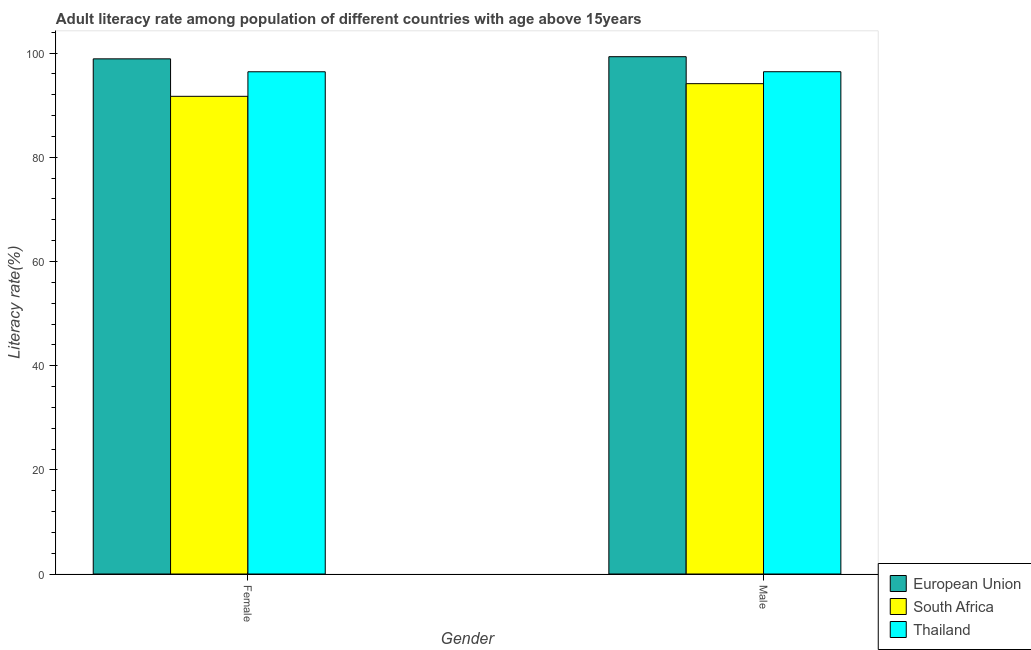How many different coloured bars are there?
Offer a very short reply. 3. What is the female adult literacy rate in Thailand?
Provide a short and direct response. 96.43. Across all countries, what is the maximum female adult literacy rate?
Ensure brevity in your answer.  98.91. Across all countries, what is the minimum male adult literacy rate?
Your response must be concise. 94.14. In which country was the female adult literacy rate maximum?
Provide a short and direct response. European Union. In which country was the female adult literacy rate minimum?
Ensure brevity in your answer.  South Africa. What is the total female adult literacy rate in the graph?
Your answer should be compact. 287.05. What is the difference between the female adult literacy rate in European Union and that in Thailand?
Make the answer very short. 2.48. What is the difference between the male adult literacy rate in European Union and the female adult literacy rate in South Africa?
Offer a very short reply. 7.61. What is the average female adult literacy rate per country?
Offer a very short reply. 95.68. What is the difference between the female adult literacy rate and male adult literacy rate in European Union?
Your answer should be very brief. -0.41. What is the ratio of the female adult literacy rate in Thailand to that in South Africa?
Ensure brevity in your answer.  1.05. Is the female adult literacy rate in Thailand less than that in European Union?
Ensure brevity in your answer.  Yes. What does the 1st bar from the left in Male represents?
Your answer should be very brief. European Union. How many bars are there?
Give a very brief answer. 6. Are all the bars in the graph horizontal?
Provide a succinct answer. No. How many countries are there in the graph?
Your answer should be compact. 3. Are the values on the major ticks of Y-axis written in scientific E-notation?
Provide a succinct answer. No. Does the graph contain any zero values?
Keep it short and to the point. No. What is the title of the graph?
Your answer should be compact. Adult literacy rate among population of different countries with age above 15years. Does "South Africa" appear as one of the legend labels in the graph?
Ensure brevity in your answer.  Yes. What is the label or title of the Y-axis?
Your answer should be very brief. Literacy rate(%). What is the Literacy rate(%) in European Union in Female?
Provide a short and direct response. 98.91. What is the Literacy rate(%) in South Africa in Female?
Offer a terse response. 91.71. What is the Literacy rate(%) of Thailand in Female?
Offer a terse response. 96.43. What is the Literacy rate(%) in European Union in Male?
Keep it short and to the point. 99.32. What is the Literacy rate(%) of South Africa in Male?
Ensure brevity in your answer.  94.14. What is the Literacy rate(%) in Thailand in Male?
Provide a succinct answer. 96.44. Across all Gender, what is the maximum Literacy rate(%) of European Union?
Your response must be concise. 99.32. Across all Gender, what is the maximum Literacy rate(%) in South Africa?
Make the answer very short. 94.14. Across all Gender, what is the maximum Literacy rate(%) of Thailand?
Your answer should be compact. 96.44. Across all Gender, what is the minimum Literacy rate(%) of European Union?
Make the answer very short. 98.91. Across all Gender, what is the minimum Literacy rate(%) of South Africa?
Keep it short and to the point. 91.71. Across all Gender, what is the minimum Literacy rate(%) of Thailand?
Give a very brief answer. 96.43. What is the total Literacy rate(%) of European Union in the graph?
Your response must be concise. 198.23. What is the total Literacy rate(%) of South Africa in the graph?
Your answer should be very brief. 185.86. What is the total Literacy rate(%) of Thailand in the graph?
Offer a terse response. 192.86. What is the difference between the Literacy rate(%) in European Union in Female and that in Male?
Provide a short and direct response. -0.41. What is the difference between the Literacy rate(%) of South Africa in Female and that in Male?
Give a very brief answer. -2.43. What is the difference between the Literacy rate(%) in Thailand in Female and that in Male?
Make the answer very short. -0.01. What is the difference between the Literacy rate(%) of European Union in Female and the Literacy rate(%) of South Africa in Male?
Ensure brevity in your answer.  4.76. What is the difference between the Literacy rate(%) of European Union in Female and the Literacy rate(%) of Thailand in Male?
Provide a succinct answer. 2.47. What is the difference between the Literacy rate(%) in South Africa in Female and the Literacy rate(%) in Thailand in Male?
Offer a very short reply. -4.72. What is the average Literacy rate(%) of European Union per Gender?
Your answer should be compact. 99.12. What is the average Literacy rate(%) of South Africa per Gender?
Provide a short and direct response. 92.93. What is the average Literacy rate(%) in Thailand per Gender?
Keep it short and to the point. 96.43. What is the difference between the Literacy rate(%) of European Union and Literacy rate(%) of South Africa in Female?
Ensure brevity in your answer.  7.19. What is the difference between the Literacy rate(%) in European Union and Literacy rate(%) in Thailand in Female?
Your answer should be compact. 2.48. What is the difference between the Literacy rate(%) in South Africa and Literacy rate(%) in Thailand in Female?
Make the answer very short. -4.71. What is the difference between the Literacy rate(%) of European Union and Literacy rate(%) of South Africa in Male?
Make the answer very short. 5.18. What is the difference between the Literacy rate(%) in European Union and Literacy rate(%) in Thailand in Male?
Make the answer very short. 2.89. What is the difference between the Literacy rate(%) in South Africa and Literacy rate(%) in Thailand in Male?
Provide a short and direct response. -2.29. What is the ratio of the Literacy rate(%) of South Africa in Female to that in Male?
Your answer should be very brief. 0.97. What is the ratio of the Literacy rate(%) of Thailand in Female to that in Male?
Give a very brief answer. 1. What is the difference between the highest and the second highest Literacy rate(%) in European Union?
Make the answer very short. 0.41. What is the difference between the highest and the second highest Literacy rate(%) in South Africa?
Provide a succinct answer. 2.43. What is the difference between the highest and the second highest Literacy rate(%) in Thailand?
Make the answer very short. 0.01. What is the difference between the highest and the lowest Literacy rate(%) of European Union?
Ensure brevity in your answer.  0.41. What is the difference between the highest and the lowest Literacy rate(%) in South Africa?
Make the answer very short. 2.43. What is the difference between the highest and the lowest Literacy rate(%) of Thailand?
Your answer should be compact. 0.01. 